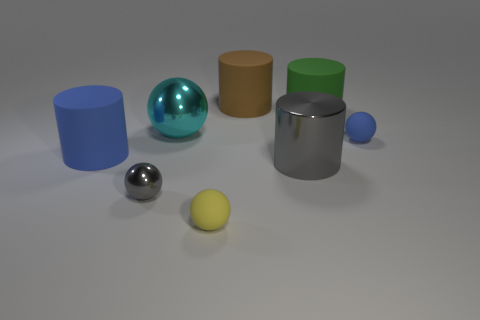Subtract all big green rubber cylinders. How many cylinders are left? 3 Add 1 tiny purple rubber spheres. How many objects exist? 9 Subtract 1 cylinders. How many cylinders are left? 3 Subtract all purple cylinders. Subtract all green blocks. How many cylinders are left? 4 Subtract all big green rubber things. Subtract all matte objects. How many objects are left? 2 Add 3 cyan balls. How many cyan balls are left? 4 Add 6 metallic things. How many metallic things exist? 9 Subtract all cyan spheres. How many spheres are left? 3 Subtract 0 purple blocks. How many objects are left? 8 